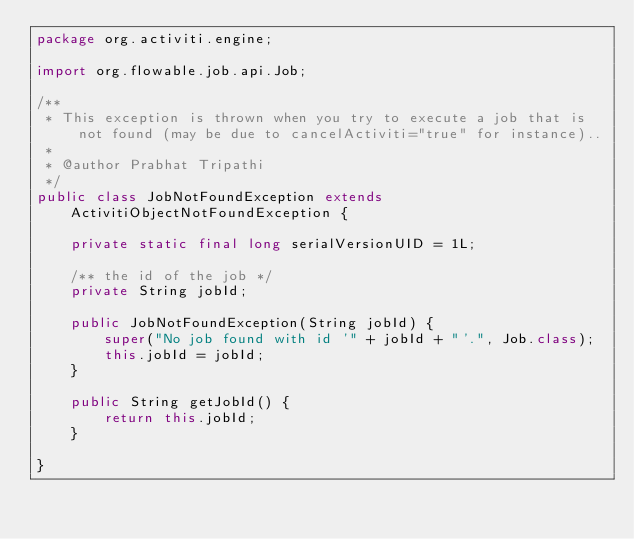Convert code to text. <code><loc_0><loc_0><loc_500><loc_500><_Java_>package org.activiti.engine;

import org.flowable.job.api.Job;

/**
 * This exception is thrown when you try to execute a job that is not found (may be due to cancelActiviti="true" for instance)..
 * 
 * @author Prabhat Tripathi
 */
public class JobNotFoundException extends ActivitiObjectNotFoundException {

    private static final long serialVersionUID = 1L;

    /** the id of the job */
    private String jobId;

    public JobNotFoundException(String jobId) {
        super("No job found with id '" + jobId + "'.", Job.class);
        this.jobId = jobId;
    }

    public String getJobId() {
        return this.jobId;
    }

}
</code> 